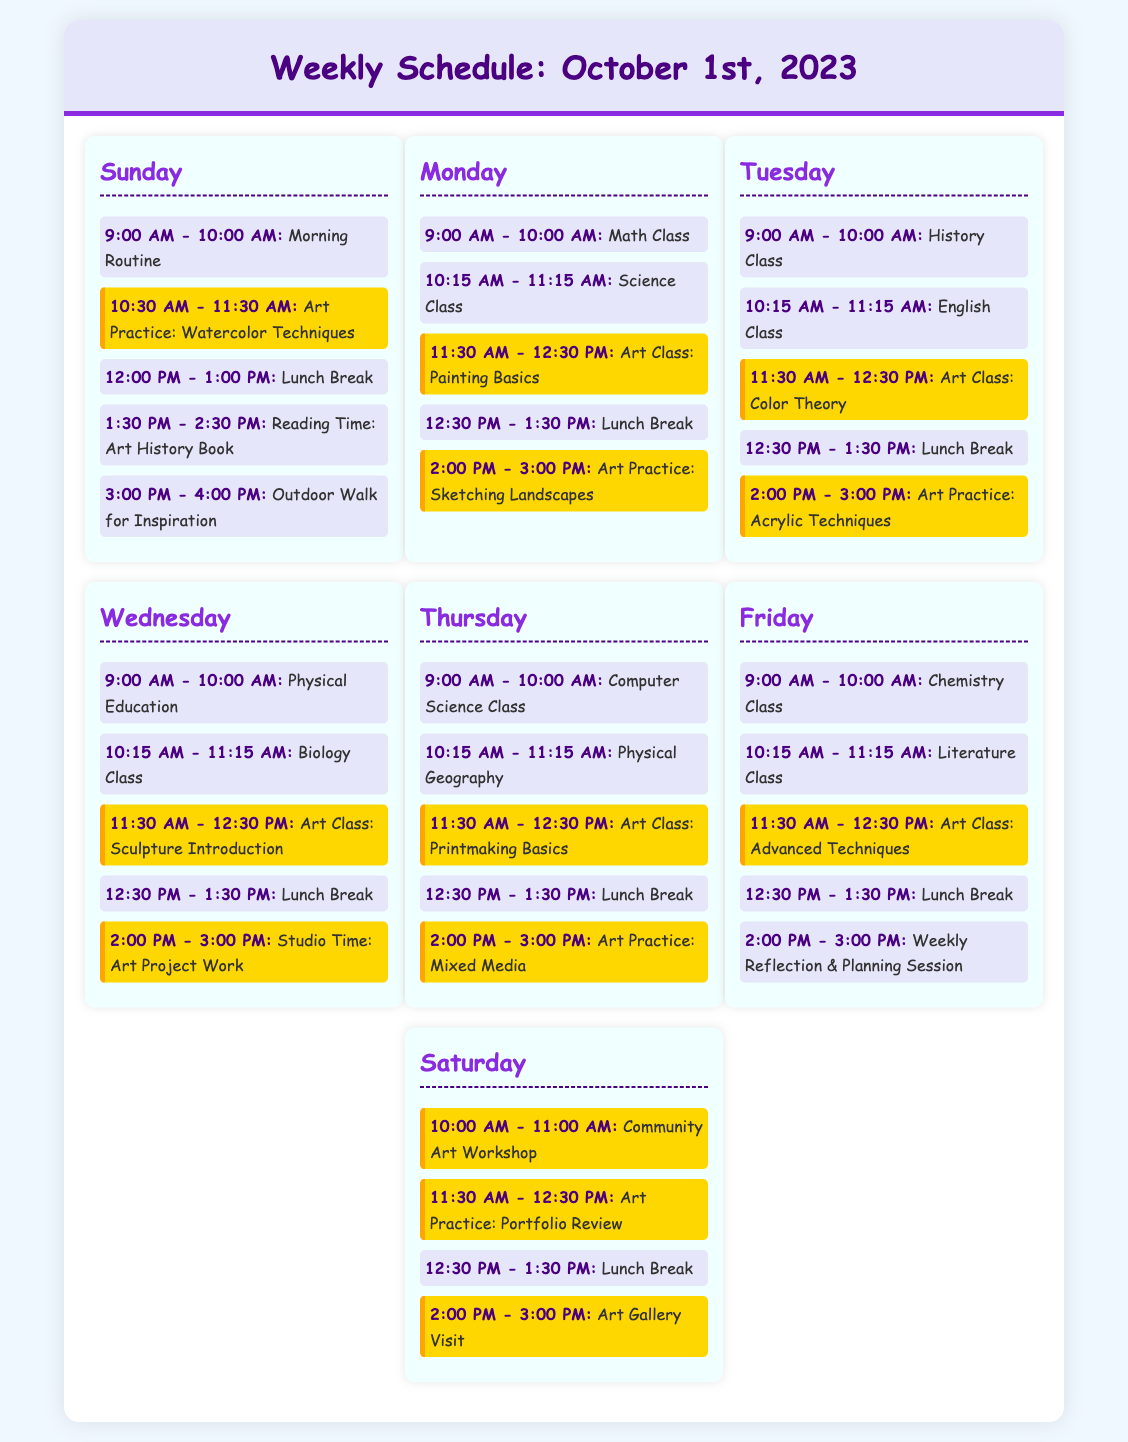What day has the Art Practice: Watercolor Techniques? The question asks for the day associated with a specific art practice mentioned in the document. The answer appears in the Sunday section.
Answer: Sunday What time does the Art Class: Printmaking Basics occur on Thursday? This question seeks the specific time of an art class on a particular day, found in the Thursday schedule.
Answer: 11:30 AM - 12:30 PM How many Lunch Breaks are scheduled within the week? This question involves counting the instances of lunch breaks across all days listed in the schedule.
Answer: 6 What class is scheduled right before the Art Class: Advanced Techniques on Friday? This question requires reasoning to identify which class comes immediately prior to an art class on Friday's schedule.
Answer: Literature Class On which day is the Art Gallery Visit scheduled? This asks for the specific day allocated for visiting an art gallery, referenced in the Saturday lineup.
Answer: Saturday 